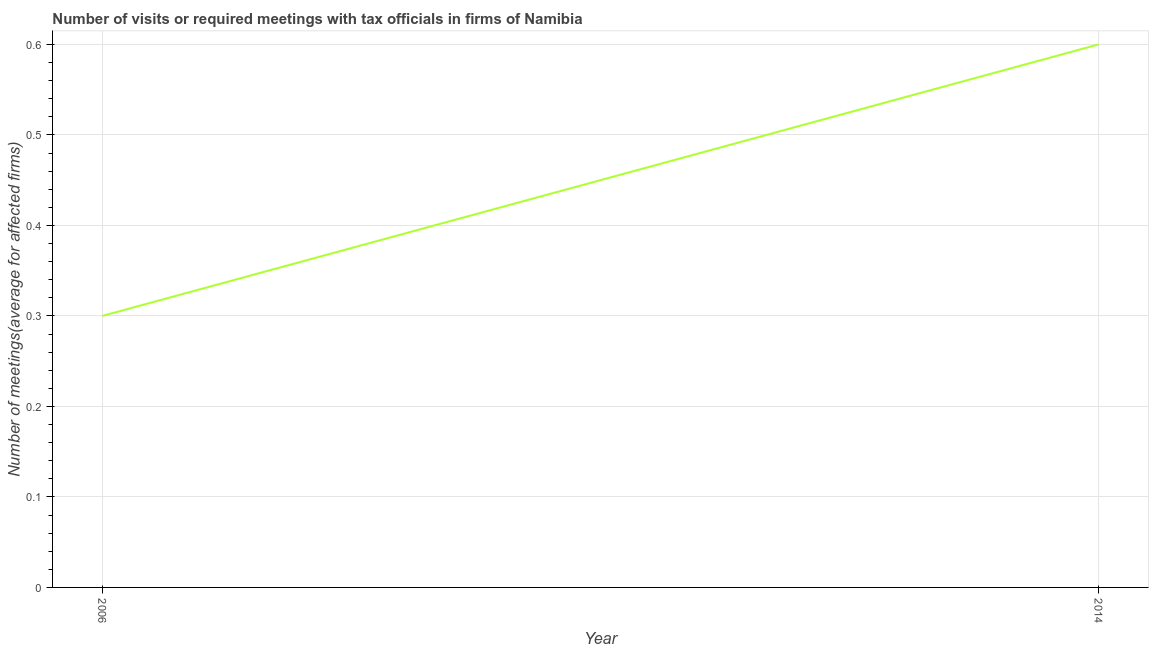What is the number of required meetings with tax officials in 2006?
Provide a succinct answer. 0.3. In which year was the number of required meetings with tax officials maximum?
Your response must be concise. 2014. In which year was the number of required meetings with tax officials minimum?
Make the answer very short. 2006. What is the sum of the number of required meetings with tax officials?
Provide a short and direct response. 0.9. What is the difference between the number of required meetings with tax officials in 2006 and 2014?
Make the answer very short. -0.3. What is the average number of required meetings with tax officials per year?
Provide a short and direct response. 0.45. What is the median number of required meetings with tax officials?
Give a very brief answer. 0.45. Do a majority of the years between 2006 and 2014 (inclusive) have number of required meetings with tax officials greater than 0.02 ?
Offer a very short reply. Yes. In how many years, is the number of required meetings with tax officials greater than the average number of required meetings with tax officials taken over all years?
Your answer should be compact. 1. Does the number of required meetings with tax officials monotonically increase over the years?
Offer a terse response. Yes. How many lines are there?
Provide a short and direct response. 1. What is the difference between two consecutive major ticks on the Y-axis?
Provide a succinct answer. 0.1. Are the values on the major ticks of Y-axis written in scientific E-notation?
Provide a short and direct response. No. Does the graph contain grids?
Give a very brief answer. Yes. What is the title of the graph?
Provide a short and direct response. Number of visits or required meetings with tax officials in firms of Namibia. What is the label or title of the Y-axis?
Your answer should be compact. Number of meetings(average for affected firms). What is the Number of meetings(average for affected firms) of 2006?
Keep it short and to the point. 0.3. What is the difference between the Number of meetings(average for affected firms) in 2006 and 2014?
Offer a terse response. -0.3. 